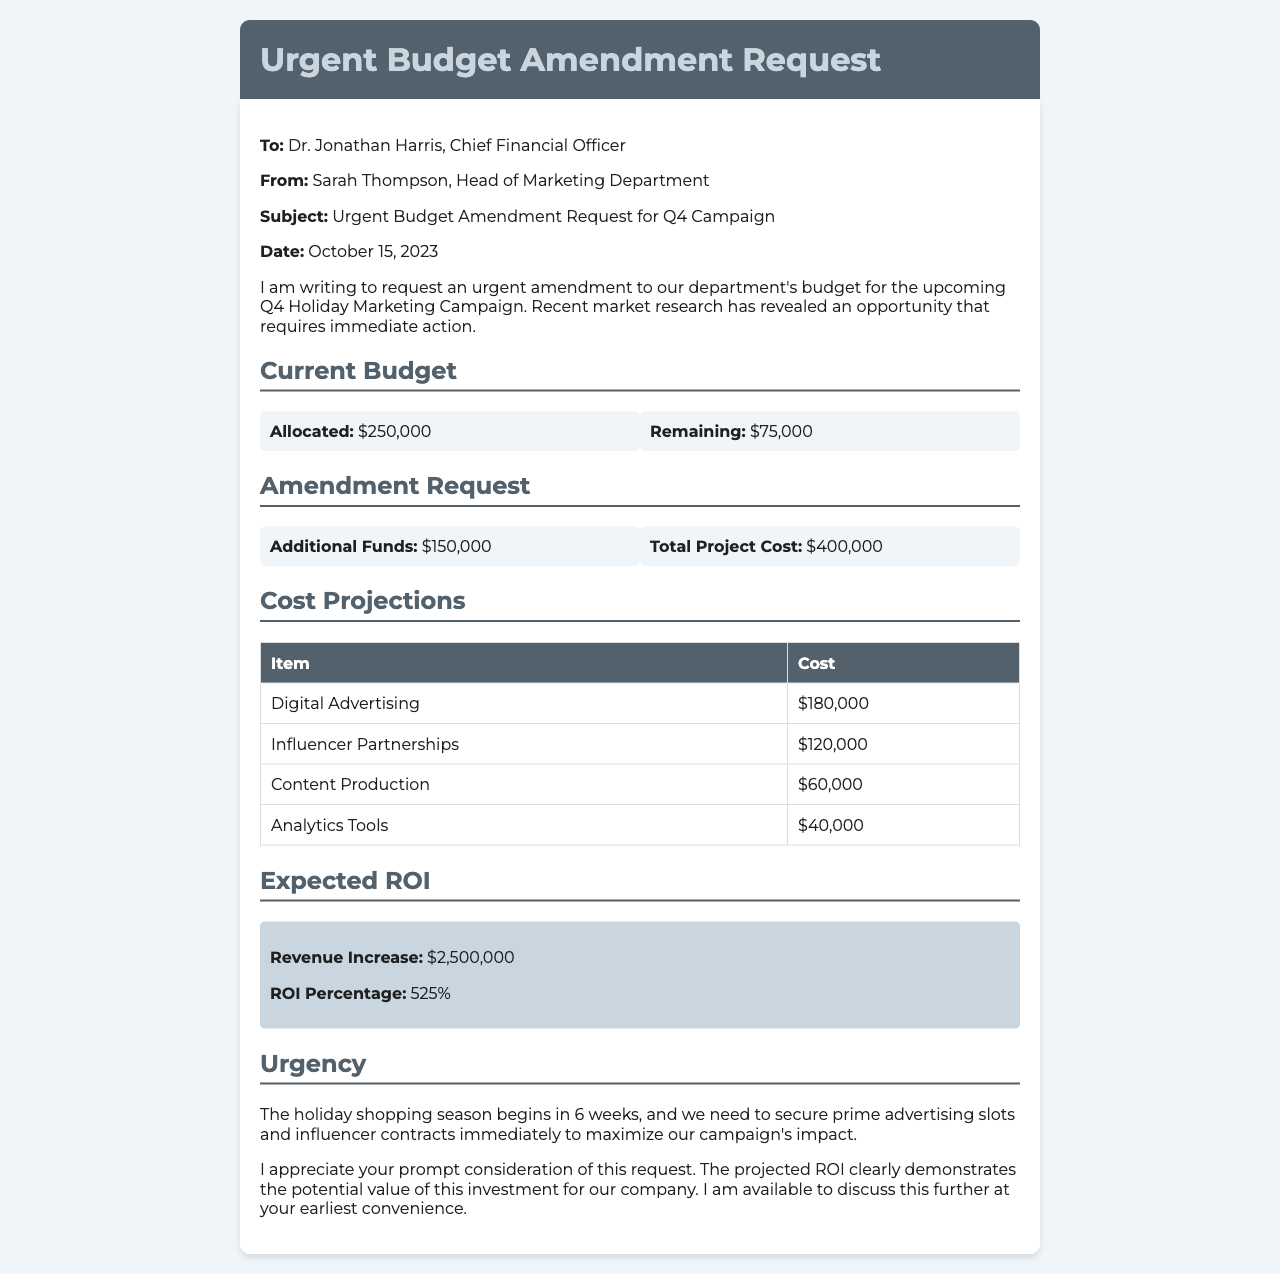what is the date of the budget amendment request? The date mentioned in the document for the budget amendment request is October 15, 2023.
Answer: October 15, 2023 who is the sender of this fax? The sender of the fax is Sarah Thompson, the Head of Marketing Department.
Answer: Sarah Thompson what is the total project cost? The total project cost mentioned in the document is $400,000.
Answer: $400,000 how much additional funds are requested? The additional funds requested in the document amount to $150,000.
Answer: $150,000 what is the expected ROI percentage? The expected ROI percentage stated in the document is 525%.
Answer: 525% how much is allocated for the current budget? The allocated amount for the current budget is $250,000.
Answer: $250,000 which item has the highest projected cost? The item with the highest projected cost is Digital Advertising at $180,000.
Answer: Digital Advertising why is there urgency in this request? There is urgency because the holiday shopping season begins in 6 weeks and immediate action is needed to secure advertising slots.
Answer: 6 weeks who is the recipient of the fax? The recipient of the fax is Dr. Jonathan Harris, Chief Financial Officer.
Answer: Dr. Jonathan Harris 